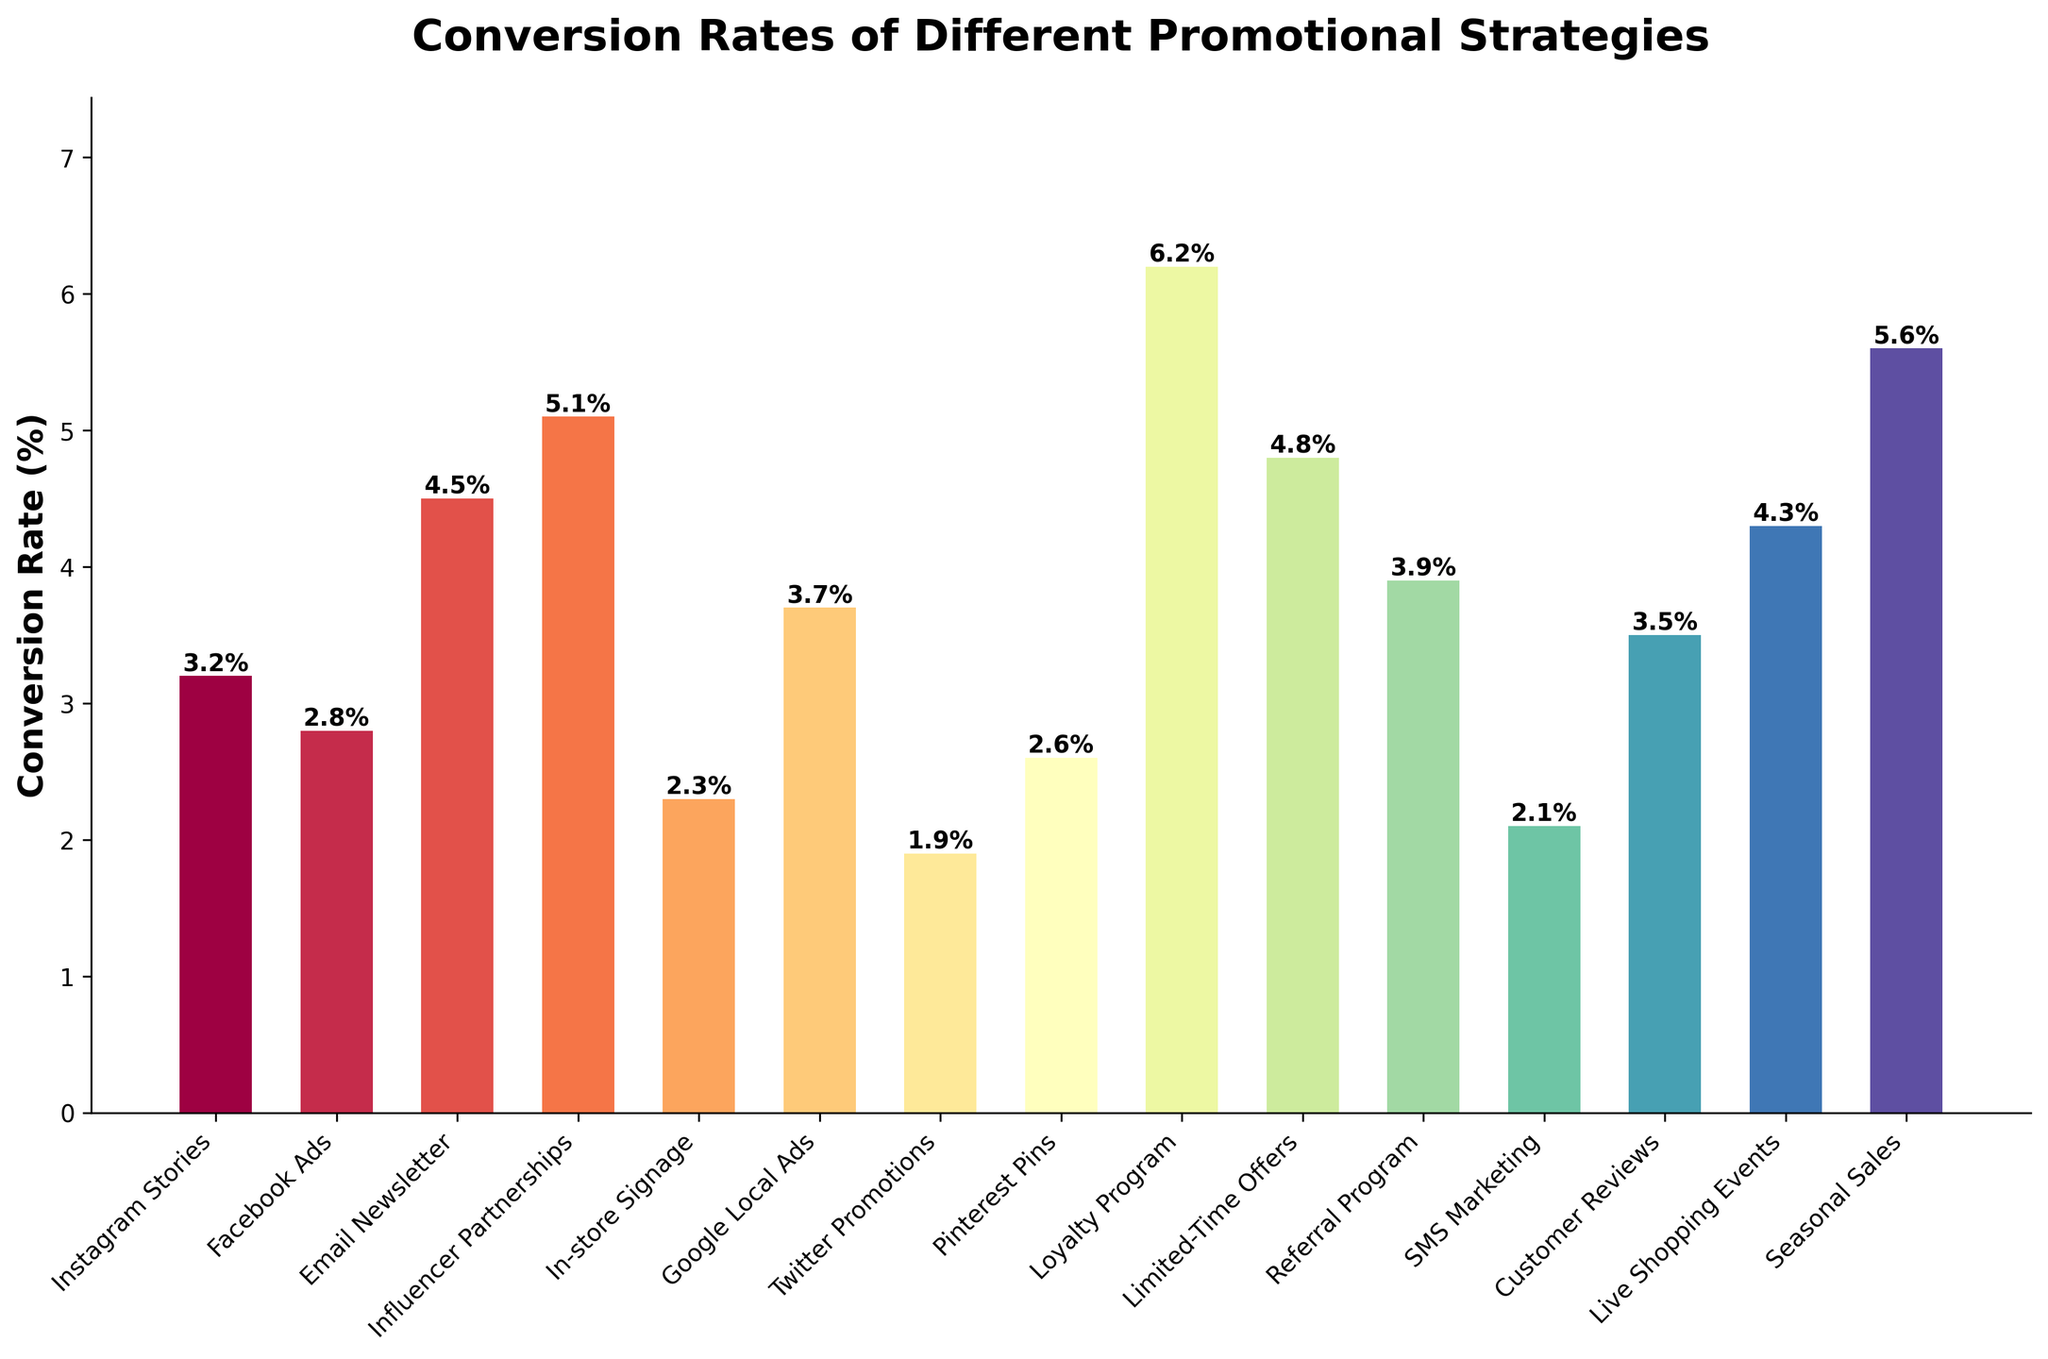What's the strategy with the highest conversion rate? First, observe all the bars in the bar chart. Identify the bar with the greatest height. The label for this bar indicates the strategy with the highest conversion rate. From the chart, the Loyalty Program has the highest conversion rate.
Answer: Loyalty Program Which strategy has a higher conversion rate: Email Newsletter or Facebook Ads? Look at the heights of the bars labeled 'Email Newsletter' and 'Facebook Ads'. The Email Newsletter bar is taller than the Facebook Ads bar. Thus, Email Newsletter has a higher conversion rate.
Answer: Email Newsletter What's the difference in conversion rate between Influencer Partnerships and Twitter Promotions? Find the conversion rates for both Influencer Partnerships and Twitter Promotions from the heights or labels on the bars. Influencer Partnerships have a conversion rate of 5.1% and Twitter Promotions have 1.9%. Subtract the smaller value from the larger one: 5.1% - 1.9% = 3.2%.
Answer: 3.2% What's the average conversion rate of Instagram Stories, Google Local Ads, and Seasonal Sales? Identify the conversion rates for Instagram Stories (3.2%), Google Local Ads (3.7%), and Seasonal Sales (5.6%). Add them up: 3.2% + 3.7% + 5.6% = 12.5%. Divide by the number of items (3): 12.5% / 3 ≈ 4.17%.
Answer: 4.17% How many strategies have a conversion rate above 4%? Examine each bar and count the ones that have a height corresponding to a conversion rate above 4%. The strategies are Email Newsletter (4.5%), Influencer Partnerships (5.1%), Limited-Time Offers (4.8%), Referral Program (3.9% does not count), Seasonal Sales (5.6%), and Loyalty Program (6.2%). There are 5 strategies.
Answer: 5 Which strategy has the second-lowest conversion rate? Order the bars from shortest to tallest and identify the second shortest. The shortest bar is Twitter Promotions (1.9%), and the second shortest is SMS Marketing (2.1%). Thus, SMS Marketing has the second-lowest conversion rate.
Answer: SMS Marketing Is the conversion rate of Limited-Time Offers greater than the combined conversion rates of In-store Signage and SMS Marketing? Find the conversion rates for Limited-Time Offers (4.8%), In-store Signage (2.3%), and SMS Marketing (2.1%). Sum the rates for In-store Signage and SMS Marketing: 2.3% + 2.1% = 4.4%. Compare 4.8% and 4.4%. Since 4.8% > 4.4%, the answer is yes.
Answer: Yes What's the conversion rate range among all strategies? Identify the highest and lowest conversion rates from the chart. The highest is Loyalty Program (6.2%) and the lowest is Twitter Promotions (1.9%). Calculate the range: 6.2% - 1.9% = 4.3%.
Answer: 4.3% Are the conversion rates of Google Local Ads and Customer Reviews equal? Compare the bar heights for Google Local Ads and Customer Reviews. Google Local Ads has a conversion rate of 3.7% and Customer Reviews has 3.5%. They are not equal.
Answer: No 